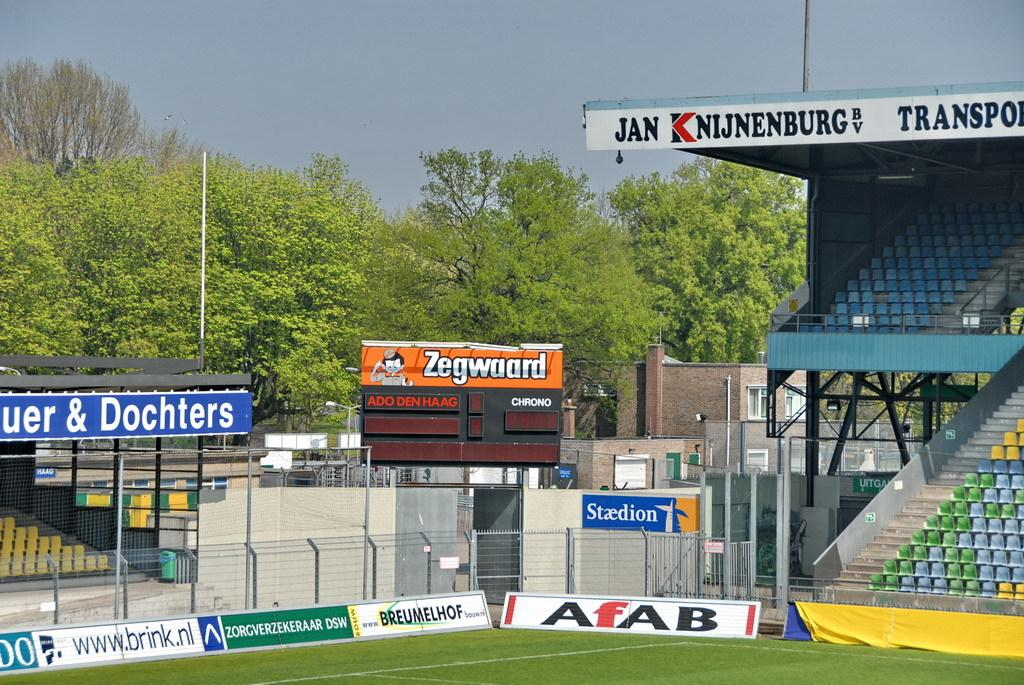What type of vegetation is present in the image? There is grass in the image. What structures can be seen in the image? There are boards, a fence, chairs, poles, and a building in the image. What other natural elements are visible in the image? There are trees in the image. What is visible in the background of the image? The sky is visible in the background of the image. Can you see any fruit hanging from the trees in the image? There is no fruit visible in the image; only trees are present. Are there any fairies flying around the chairs in the image? There are no fairies present in the image; only chairs, trees, and other structures are visible. 